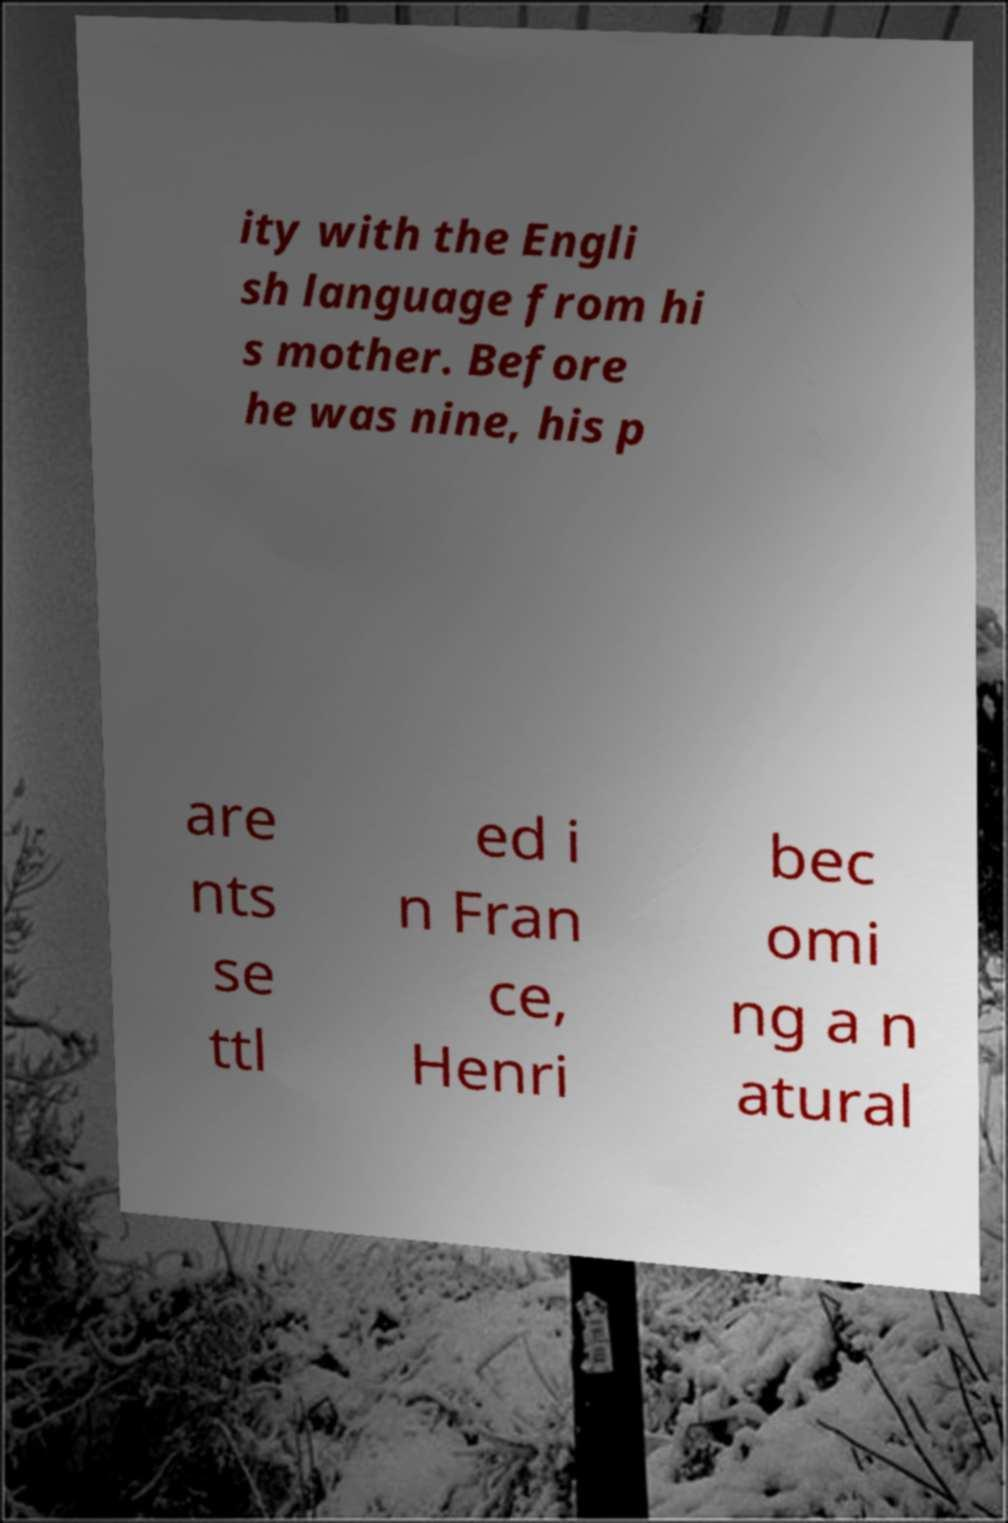Please read and relay the text visible in this image. What does it say? ity with the Engli sh language from hi s mother. Before he was nine, his p are nts se ttl ed i n Fran ce, Henri bec omi ng a n atural 